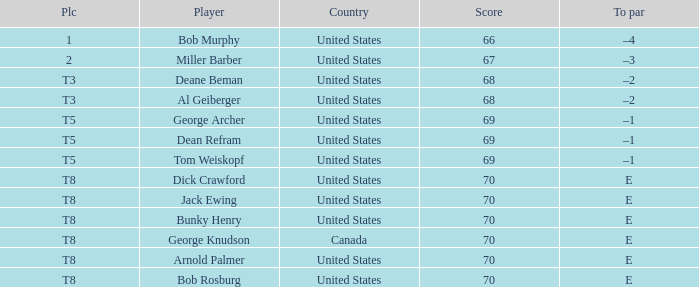Parse the full table. {'header': ['Plc', 'Player', 'Country', 'Score', 'To par'], 'rows': [['1', 'Bob Murphy', 'United States', '66', '–4'], ['2', 'Miller Barber', 'United States', '67', '–3'], ['T3', 'Deane Beman', 'United States', '68', '–2'], ['T3', 'Al Geiberger', 'United States', '68', '–2'], ['T5', 'George Archer', 'United States', '69', '–1'], ['T5', 'Dean Refram', 'United States', '69', '–1'], ['T5', 'Tom Weiskopf', 'United States', '69', '–1'], ['T8', 'Dick Crawford', 'United States', '70', 'E'], ['T8', 'Jack Ewing', 'United States', '70', 'E'], ['T8', 'Bunky Henry', 'United States', '70', 'E'], ['T8', 'George Knudson', 'Canada', '70', 'E'], ['T8', 'Arnold Palmer', 'United States', '70', 'E'], ['T8', 'Bob Rosburg', 'United States', '70', 'E']]} When Bunky Henry of the United States scored higher than 67 and his To par was e, what was his place? T8. 